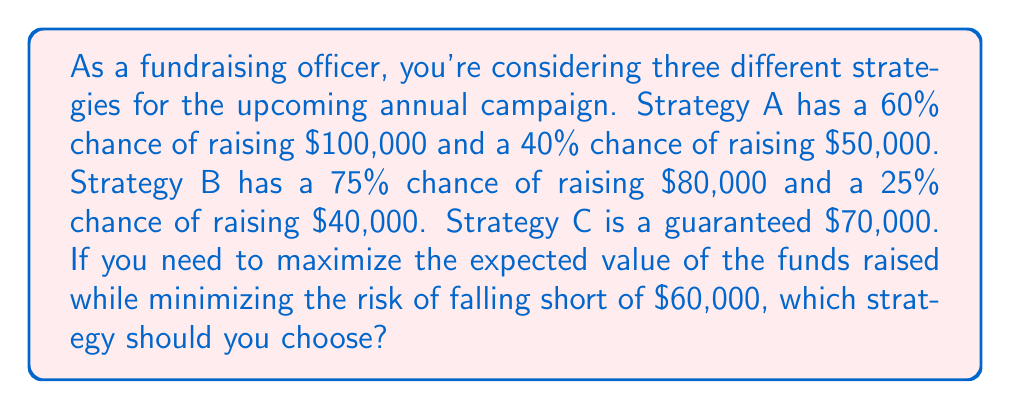Provide a solution to this math problem. To solve this problem, we need to calculate the expected value for each strategy and assess the risk of falling short of $60,000.

1. Calculate the expected value for each strategy:

Strategy A:
$E(A) = 0.60 \times \$100,000 + 0.40 \times \$50,000 = \$60,000 + \$20,000 = \$80,000$

Strategy B:
$E(B) = 0.75 \times \$80,000 + 0.25 \times \$40,000 = \$60,000 + \$10,000 = \$70,000$

Strategy C:
$E(C) = \$70,000$ (guaranteed)

2. Assess the risk of falling short of $60,000:

Strategy A: 40% chance of raising only $50,000, which is below $60,000
Strategy B: 25% chance of raising only $40,000, which is below $60,000
Strategy C: 0% chance of falling short of $60,000 (guaranteed $70,000)

3. Decision analysis:

Strategy A has the highest expected value at $80,000, but it also has a significant risk (40%) of falling short of the $60,000 target.

Strategy B has a lower expected value of $70,000 and a lower risk (25%) of falling short of the target.

Strategy C has the same expected value as Strategy B ($70,000) but with no risk of falling short of the target.

Considering both the expected value and the risk, Strategy C is the best choice. It provides a guaranteed amount that meets the minimum target of $60,000 and has an expected value equal to Strategy B. While it doesn't offer the highest potential return, it eliminates the risk of falling short of the target, which is crucial for maintaining consistent fundraising efforts and balancing the demands of the job.
Answer: Strategy C: Guaranteed $70,000 